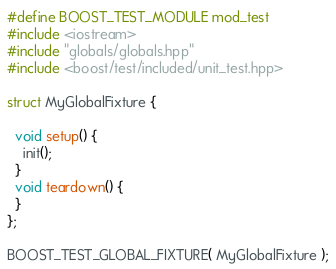Convert code to text. <code><loc_0><loc_0><loc_500><loc_500><_C++_>#define BOOST_TEST_MODULE mod_test
#include <iostream>
#include "globals/globals.hpp"
#include <boost/test/included/unit_test.hpp>

struct MyGlobalFixture {

  void setup() {
    init();
  }
  void teardown() {
  }
};

BOOST_TEST_GLOBAL_FIXTURE( MyGlobalFixture );
</code> 